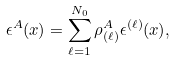Convert formula to latex. <formula><loc_0><loc_0><loc_500><loc_500>\epsilon ^ { A } ( x ) = \sum _ { \ell = 1 } ^ { N _ { 0 } } \rho _ { ( \ell ) } ^ { A } \epsilon ^ { ( \ell ) } ( x ) ,</formula> 